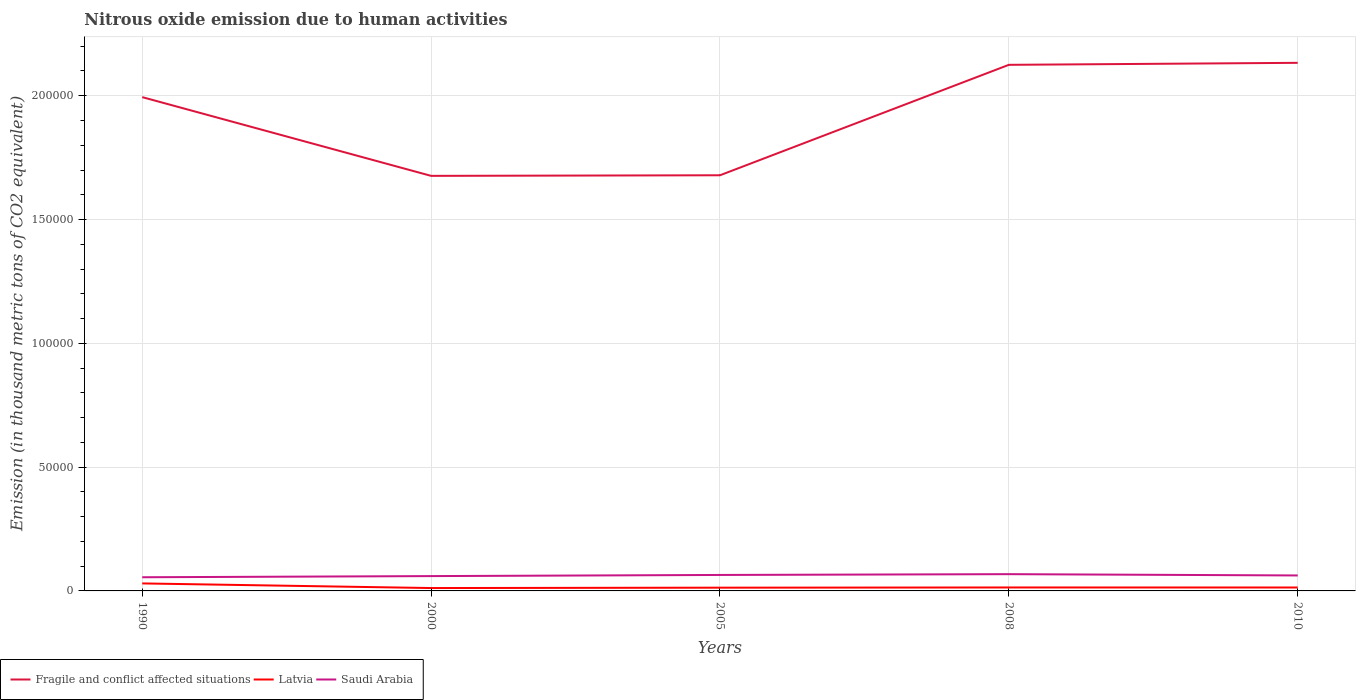Across all years, what is the maximum amount of nitrous oxide emitted in Saudi Arabia?
Your response must be concise. 5523.5. In which year was the amount of nitrous oxide emitted in Latvia maximum?
Give a very brief answer. 2000. What is the total amount of nitrous oxide emitted in Latvia in the graph?
Provide a succinct answer. 1872.4. What is the difference between the highest and the second highest amount of nitrous oxide emitted in Saudi Arabia?
Your answer should be very brief. 1249.7. How many lines are there?
Offer a very short reply. 3. Are the values on the major ticks of Y-axis written in scientific E-notation?
Make the answer very short. No. How many legend labels are there?
Your answer should be very brief. 3. How are the legend labels stacked?
Provide a short and direct response. Horizontal. What is the title of the graph?
Ensure brevity in your answer.  Nitrous oxide emission due to human activities. Does "Netherlands" appear as one of the legend labels in the graph?
Provide a succinct answer. No. What is the label or title of the Y-axis?
Your response must be concise. Emission (in thousand metric tons of CO2 equivalent). What is the Emission (in thousand metric tons of CO2 equivalent) of Fragile and conflict affected situations in 1990?
Your answer should be compact. 1.99e+05. What is the Emission (in thousand metric tons of CO2 equivalent) of Latvia in 1990?
Make the answer very short. 3031.8. What is the Emission (in thousand metric tons of CO2 equivalent) in Saudi Arabia in 1990?
Provide a short and direct response. 5523.5. What is the Emission (in thousand metric tons of CO2 equivalent) in Fragile and conflict affected situations in 2000?
Offer a very short reply. 1.68e+05. What is the Emission (in thousand metric tons of CO2 equivalent) in Latvia in 2000?
Make the answer very short. 1159.4. What is the Emission (in thousand metric tons of CO2 equivalent) of Saudi Arabia in 2000?
Make the answer very short. 5988.8. What is the Emission (in thousand metric tons of CO2 equivalent) in Fragile and conflict affected situations in 2005?
Your response must be concise. 1.68e+05. What is the Emission (in thousand metric tons of CO2 equivalent) in Latvia in 2005?
Make the answer very short. 1311.8. What is the Emission (in thousand metric tons of CO2 equivalent) in Saudi Arabia in 2005?
Give a very brief answer. 6446.5. What is the Emission (in thousand metric tons of CO2 equivalent) of Fragile and conflict affected situations in 2008?
Keep it short and to the point. 2.12e+05. What is the Emission (in thousand metric tons of CO2 equivalent) in Latvia in 2008?
Your answer should be very brief. 1391.9. What is the Emission (in thousand metric tons of CO2 equivalent) in Saudi Arabia in 2008?
Provide a succinct answer. 6773.2. What is the Emission (in thousand metric tons of CO2 equivalent) of Fragile and conflict affected situations in 2010?
Give a very brief answer. 2.13e+05. What is the Emission (in thousand metric tons of CO2 equivalent) in Latvia in 2010?
Give a very brief answer. 1383. What is the Emission (in thousand metric tons of CO2 equivalent) of Saudi Arabia in 2010?
Offer a terse response. 6248.8. Across all years, what is the maximum Emission (in thousand metric tons of CO2 equivalent) in Fragile and conflict affected situations?
Make the answer very short. 2.13e+05. Across all years, what is the maximum Emission (in thousand metric tons of CO2 equivalent) in Latvia?
Your answer should be compact. 3031.8. Across all years, what is the maximum Emission (in thousand metric tons of CO2 equivalent) in Saudi Arabia?
Provide a short and direct response. 6773.2. Across all years, what is the minimum Emission (in thousand metric tons of CO2 equivalent) of Fragile and conflict affected situations?
Keep it short and to the point. 1.68e+05. Across all years, what is the minimum Emission (in thousand metric tons of CO2 equivalent) in Latvia?
Your response must be concise. 1159.4. Across all years, what is the minimum Emission (in thousand metric tons of CO2 equivalent) in Saudi Arabia?
Your answer should be very brief. 5523.5. What is the total Emission (in thousand metric tons of CO2 equivalent) of Fragile and conflict affected situations in the graph?
Provide a succinct answer. 9.61e+05. What is the total Emission (in thousand metric tons of CO2 equivalent) of Latvia in the graph?
Make the answer very short. 8277.9. What is the total Emission (in thousand metric tons of CO2 equivalent) in Saudi Arabia in the graph?
Ensure brevity in your answer.  3.10e+04. What is the difference between the Emission (in thousand metric tons of CO2 equivalent) in Fragile and conflict affected situations in 1990 and that in 2000?
Offer a very short reply. 3.18e+04. What is the difference between the Emission (in thousand metric tons of CO2 equivalent) of Latvia in 1990 and that in 2000?
Make the answer very short. 1872.4. What is the difference between the Emission (in thousand metric tons of CO2 equivalent) in Saudi Arabia in 1990 and that in 2000?
Your answer should be very brief. -465.3. What is the difference between the Emission (in thousand metric tons of CO2 equivalent) in Fragile and conflict affected situations in 1990 and that in 2005?
Your answer should be compact. 3.16e+04. What is the difference between the Emission (in thousand metric tons of CO2 equivalent) in Latvia in 1990 and that in 2005?
Your answer should be very brief. 1720. What is the difference between the Emission (in thousand metric tons of CO2 equivalent) of Saudi Arabia in 1990 and that in 2005?
Keep it short and to the point. -923. What is the difference between the Emission (in thousand metric tons of CO2 equivalent) in Fragile and conflict affected situations in 1990 and that in 2008?
Offer a very short reply. -1.30e+04. What is the difference between the Emission (in thousand metric tons of CO2 equivalent) of Latvia in 1990 and that in 2008?
Your response must be concise. 1639.9. What is the difference between the Emission (in thousand metric tons of CO2 equivalent) of Saudi Arabia in 1990 and that in 2008?
Keep it short and to the point. -1249.7. What is the difference between the Emission (in thousand metric tons of CO2 equivalent) in Fragile and conflict affected situations in 1990 and that in 2010?
Offer a terse response. -1.38e+04. What is the difference between the Emission (in thousand metric tons of CO2 equivalent) in Latvia in 1990 and that in 2010?
Your answer should be very brief. 1648.8. What is the difference between the Emission (in thousand metric tons of CO2 equivalent) in Saudi Arabia in 1990 and that in 2010?
Offer a terse response. -725.3. What is the difference between the Emission (in thousand metric tons of CO2 equivalent) in Fragile and conflict affected situations in 2000 and that in 2005?
Your answer should be very brief. -238.1. What is the difference between the Emission (in thousand metric tons of CO2 equivalent) in Latvia in 2000 and that in 2005?
Ensure brevity in your answer.  -152.4. What is the difference between the Emission (in thousand metric tons of CO2 equivalent) in Saudi Arabia in 2000 and that in 2005?
Offer a very short reply. -457.7. What is the difference between the Emission (in thousand metric tons of CO2 equivalent) of Fragile and conflict affected situations in 2000 and that in 2008?
Your answer should be very brief. -4.48e+04. What is the difference between the Emission (in thousand metric tons of CO2 equivalent) of Latvia in 2000 and that in 2008?
Offer a very short reply. -232.5. What is the difference between the Emission (in thousand metric tons of CO2 equivalent) in Saudi Arabia in 2000 and that in 2008?
Keep it short and to the point. -784.4. What is the difference between the Emission (in thousand metric tons of CO2 equivalent) in Fragile and conflict affected situations in 2000 and that in 2010?
Your answer should be compact. -4.57e+04. What is the difference between the Emission (in thousand metric tons of CO2 equivalent) of Latvia in 2000 and that in 2010?
Keep it short and to the point. -223.6. What is the difference between the Emission (in thousand metric tons of CO2 equivalent) of Saudi Arabia in 2000 and that in 2010?
Offer a very short reply. -260. What is the difference between the Emission (in thousand metric tons of CO2 equivalent) of Fragile and conflict affected situations in 2005 and that in 2008?
Ensure brevity in your answer.  -4.46e+04. What is the difference between the Emission (in thousand metric tons of CO2 equivalent) in Latvia in 2005 and that in 2008?
Provide a short and direct response. -80.1. What is the difference between the Emission (in thousand metric tons of CO2 equivalent) of Saudi Arabia in 2005 and that in 2008?
Ensure brevity in your answer.  -326.7. What is the difference between the Emission (in thousand metric tons of CO2 equivalent) of Fragile and conflict affected situations in 2005 and that in 2010?
Your answer should be compact. -4.54e+04. What is the difference between the Emission (in thousand metric tons of CO2 equivalent) of Latvia in 2005 and that in 2010?
Your answer should be very brief. -71.2. What is the difference between the Emission (in thousand metric tons of CO2 equivalent) of Saudi Arabia in 2005 and that in 2010?
Your response must be concise. 197.7. What is the difference between the Emission (in thousand metric tons of CO2 equivalent) in Fragile and conflict affected situations in 2008 and that in 2010?
Offer a terse response. -807. What is the difference between the Emission (in thousand metric tons of CO2 equivalent) of Saudi Arabia in 2008 and that in 2010?
Offer a terse response. 524.4. What is the difference between the Emission (in thousand metric tons of CO2 equivalent) of Fragile and conflict affected situations in 1990 and the Emission (in thousand metric tons of CO2 equivalent) of Latvia in 2000?
Your answer should be very brief. 1.98e+05. What is the difference between the Emission (in thousand metric tons of CO2 equivalent) in Fragile and conflict affected situations in 1990 and the Emission (in thousand metric tons of CO2 equivalent) in Saudi Arabia in 2000?
Provide a short and direct response. 1.93e+05. What is the difference between the Emission (in thousand metric tons of CO2 equivalent) in Latvia in 1990 and the Emission (in thousand metric tons of CO2 equivalent) in Saudi Arabia in 2000?
Your response must be concise. -2957. What is the difference between the Emission (in thousand metric tons of CO2 equivalent) in Fragile and conflict affected situations in 1990 and the Emission (in thousand metric tons of CO2 equivalent) in Latvia in 2005?
Provide a short and direct response. 1.98e+05. What is the difference between the Emission (in thousand metric tons of CO2 equivalent) in Fragile and conflict affected situations in 1990 and the Emission (in thousand metric tons of CO2 equivalent) in Saudi Arabia in 2005?
Offer a very short reply. 1.93e+05. What is the difference between the Emission (in thousand metric tons of CO2 equivalent) of Latvia in 1990 and the Emission (in thousand metric tons of CO2 equivalent) of Saudi Arabia in 2005?
Keep it short and to the point. -3414.7. What is the difference between the Emission (in thousand metric tons of CO2 equivalent) of Fragile and conflict affected situations in 1990 and the Emission (in thousand metric tons of CO2 equivalent) of Latvia in 2008?
Your answer should be very brief. 1.98e+05. What is the difference between the Emission (in thousand metric tons of CO2 equivalent) of Fragile and conflict affected situations in 1990 and the Emission (in thousand metric tons of CO2 equivalent) of Saudi Arabia in 2008?
Make the answer very short. 1.93e+05. What is the difference between the Emission (in thousand metric tons of CO2 equivalent) of Latvia in 1990 and the Emission (in thousand metric tons of CO2 equivalent) of Saudi Arabia in 2008?
Your answer should be very brief. -3741.4. What is the difference between the Emission (in thousand metric tons of CO2 equivalent) of Fragile and conflict affected situations in 1990 and the Emission (in thousand metric tons of CO2 equivalent) of Latvia in 2010?
Make the answer very short. 1.98e+05. What is the difference between the Emission (in thousand metric tons of CO2 equivalent) in Fragile and conflict affected situations in 1990 and the Emission (in thousand metric tons of CO2 equivalent) in Saudi Arabia in 2010?
Keep it short and to the point. 1.93e+05. What is the difference between the Emission (in thousand metric tons of CO2 equivalent) of Latvia in 1990 and the Emission (in thousand metric tons of CO2 equivalent) of Saudi Arabia in 2010?
Make the answer very short. -3217. What is the difference between the Emission (in thousand metric tons of CO2 equivalent) of Fragile and conflict affected situations in 2000 and the Emission (in thousand metric tons of CO2 equivalent) of Latvia in 2005?
Offer a terse response. 1.66e+05. What is the difference between the Emission (in thousand metric tons of CO2 equivalent) of Fragile and conflict affected situations in 2000 and the Emission (in thousand metric tons of CO2 equivalent) of Saudi Arabia in 2005?
Provide a short and direct response. 1.61e+05. What is the difference between the Emission (in thousand metric tons of CO2 equivalent) in Latvia in 2000 and the Emission (in thousand metric tons of CO2 equivalent) in Saudi Arabia in 2005?
Offer a terse response. -5287.1. What is the difference between the Emission (in thousand metric tons of CO2 equivalent) of Fragile and conflict affected situations in 2000 and the Emission (in thousand metric tons of CO2 equivalent) of Latvia in 2008?
Keep it short and to the point. 1.66e+05. What is the difference between the Emission (in thousand metric tons of CO2 equivalent) in Fragile and conflict affected situations in 2000 and the Emission (in thousand metric tons of CO2 equivalent) in Saudi Arabia in 2008?
Keep it short and to the point. 1.61e+05. What is the difference between the Emission (in thousand metric tons of CO2 equivalent) in Latvia in 2000 and the Emission (in thousand metric tons of CO2 equivalent) in Saudi Arabia in 2008?
Offer a terse response. -5613.8. What is the difference between the Emission (in thousand metric tons of CO2 equivalent) in Fragile and conflict affected situations in 2000 and the Emission (in thousand metric tons of CO2 equivalent) in Latvia in 2010?
Make the answer very short. 1.66e+05. What is the difference between the Emission (in thousand metric tons of CO2 equivalent) in Fragile and conflict affected situations in 2000 and the Emission (in thousand metric tons of CO2 equivalent) in Saudi Arabia in 2010?
Ensure brevity in your answer.  1.61e+05. What is the difference between the Emission (in thousand metric tons of CO2 equivalent) of Latvia in 2000 and the Emission (in thousand metric tons of CO2 equivalent) of Saudi Arabia in 2010?
Your answer should be very brief. -5089.4. What is the difference between the Emission (in thousand metric tons of CO2 equivalent) in Fragile and conflict affected situations in 2005 and the Emission (in thousand metric tons of CO2 equivalent) in Latvia in 2008?
Your response must be concise. 1.66e+05. What is the difference between the Emission (in thousand metric tons of CO2 equivalent) in Fragile and conflict affected situations in 2005 and the Emission (in thousand metric tons of CO2 equivalent) in Saudi Arabia in 2008?
Ensure brevity in your answer.  1.61e+05. What is the difference between the Emission (in thousand metric tons of CO2 equivalent) of Latvia in 2005 and the Emission (in thousand metric tons of CO2 equivalent) of Saudi Arabia in 2008?
Offer a terse response. -5461.4. What is the difference between the Emission (in thousand metric tons of CO2 equivalent) of Fragile and conflict affected situations in 2005 and the Emission (in thousand metric tons of CO2 equivalent) of Latvia in 2010?
Provide a succinct answer. 1.66e+05. What is the difference between the Emission (in thousand metric tons of CO2 equivalent) in Fragile and conflict affected situations in 2005 and the Emission (in thousand metric tons of CO2 equivalent) in Saudi Arabia in 2010?
Keep it short and to the point. 1.62e+05. What is the difference between the Emission (in thousand metric tons of CO2 equivalent) in Latvia in 2005 and the Emission (in thousand metric tons of CO2 equivalent) in Saudi Arabia in 2010?
Ensure brevity in your answer.  -4937. What is the difference between the Emission (in thousand metric tons of CO2 equivalent) of Fragile and conflict affected situations in 2008 and the Emission (in thousand metric tons of CO2 equivalent) of Latvia in 2010?
Give a very brief answer. 2.11e+05. What is the difference between the Emission (in thousand metric tons of CO2 equivalent) of Fragile and conflict affected situations in 2008 and the Emission (in thousand metric tons of CO2 equivalent) of Saudi Arabia in 2010?
Offer a terse response. 2.06e+05. What is the difference between the Emission (in thousand metric tons of CO2 equivalent) of Latvia in 2008 and the Emission (in thousand metric tons of CO2 equivalent) of Saudi Arabia in 2010?
Make the answer very short. -4856.9. What is the average Emission (in thousand metric tons of CO2 equivalent) of Fragile and conflict affected situations per year?
Make the answer very short. 1.92e+05. What is the average Emission (in thousand metric tons of CO2 equivalent) of Latvia per year?
Provide a succinct answer. 1655.58. What is the average Emission (in thousand metric tons of CO2 equivalent) of Saudi Arabia per year?
Give a very brief answer. 6196.16. In the year 1990, what is the difference between the Emission (in thousand metric tons of CO2 equivalent) in Fragile and conflict affected situations and Emission (in thousand metric tons of CO2 equivalent) in Latvia?
Offer a terse response. 1.96e+05. In the year 1990, what is the difference between the Emission (in thousand metric tons of CO2 equivalent) of Fragile and conflict affected situations and Emission (in thousand metric tons of CO2 equivalent) of Saudi Arabia?
Your answer should be very brief. 1.94e+05. In the year 1990, what is the difference between the Emission (in thousand metric tons of CO2 equivalent) of Latvia and Emission (in thousand metric tons of CO2 equivalent) of Saudi Arabia?
Ensure brevity in your answer.  -2491.7. In the year 2000, what is the difference between the Emission (in thousand metric tons of CO2 equivalent) of Fragile and conflict affected situations and Emission (in thousand metric tons of CO2 equivalent) of Latvia?
Provide a short and direct response. 1.66e+05. In the year 2000, what is the difference between the Emission (in thousand metric tons of CO2 equivalent) in Fragile and conflict affected situations and Emission (in thousand metric tons of CO2 equivalent) in Saudi Arabia?
Your response must be concise. 1.62e+05. In the year 2000, what is the difference between the Emission (in thousand metric tons of CO2 equivalent) of Latvia and Emission (in thousand metric tons of CO2 equivalent) of Saudi Arabia?
Ensure brevity in your answer.  -4829.4. In the year 2005, what is the difference between the Emission (in thousand metric tons of CO2 equivalent) of Fragile and conflict affected situations and Emission (in thousand metric tons of CO2 equivalent) of Latvia?
Give a very brief answer. 1.67e+05. In the year 2005, what is the difference between the Emission (in thousand metric tons of CO2 equivalent) of Fragile and conflict affected situations and Emission (in thousand metric tons of CO2 equivalent) of Saudi Arabia?
Offer a terse response. 1.61e+05. In the year 2005, what is the difference between the Emission (in thousand metric tons of CO2 equivalent) in Latvia and Emission (in thousand metric tons of CO2 equivalent) in Saudi Arabia?
Give a very brief answer. -5134.7. In the year 2008, what is the difference between the Emission (in thousand metric tons of CO2 equivalent) of Fragile and conflict affected situations and Emission (in thousand metric tons of CO2 equivalent) of Latvia?
Provide a succinct answer. 2.11e+05. In the year 2008, what is the difference between the Emission (in thousand metric tons of CO2 equivalent) in Fragile and conflict affected situations and Emission (in thousand metric tons of CO2 equivalent) in Saudi Arabia?
Provide a succinct answer. 2.06e+05. In the year 2008, what is the difference between the Emission (in thousand metric tons of CO2 equivalent) of Latvia and Emission (in thousand metric tons of CO2 equivalent) of Saudi Arabia?
Your response must be concise. -5381.3. In the year 2010, what is the difference between the Emission (in thousand metric tons of CO2 equivalent) of Fragile and conflict affected situations and Emission (in thousand metric tons of CO2 equivalent) of Latvia?
Make the answer very short. 2.12e+05. In the year 2010, what is the difference between the Emission (in thousand metric tons of CO2 equivalent) in Fragile and conflict affected situations and Emission (in thousand metric tons of CO2 equivalent) in Saudi Arabia?
Make the answer very short. 2.07e+05. In the year 2010, what is the difference between the Emission (in thousand metric tons of CO2 equivalent) in Latvia and Emission (in thousand metric tons of CO2 equivalent) in Saudi Arabia?
Your answer should be compact. -4865.8. What is the ratio of the Emission (in thousand metric tons of CO2 equivalent) in Fragile and conflict affected situations in 1990 to that in 2000?
Your answer should be very brief. 1.19. What is the ratio of the Emission (in thousand metric tons of CO2 equivalent) of Latvia in 1990 to that in 2000?
Make the answer very short. 2.62. What is the ratio of the Emission (in thousand metric tons of CO2 equivalent) of Saudi Arabia in 1990 to that in 2000?
Make the answer very short. 0.92. What is the ratio of the Emission (in thousand metric tons of CO2 equivalent) in Fragile and conflict affected situations in 1990 to that in 2005?
Offer a terse response. 1.19. What is the ratio of the Emission (in thousand metric tons of CO2 equivalent) of Latvia in 1990 to that in 2005?
Provide a short and direct response. 2.31. What is the ratio of the Emission (in thousand metric tons of CO2 equivalent) in Saudi Arabia in 1990 to that in 2005?
Your answer should be very brief. 0.86. What is the ratio of the Emission (in thousand metric tons of CO2 equivalent) of Fragile and conflict affected situations in 1990 to that in 2008?
Make the answer very short. 0.94. What is the ratio of the Emission (in thousand metric tons of CO2 equivalent) in Latvia in 1990 to that in 2008?
Offer a terse response. 2.18. What is the ratio of the Emission (in thousand metric tons of CO2 equivalent) in Saudi Arabia in 1990 to that in 2008?
Your answer should be very brief. 0.82. What is the ratio of the Emission (in thousand metric tons of CO2 equivalent) in Fragile and conflict affected situations in 1990 to that in 2010?
Provide a succinct answer. 0.94. What is the ratio of the Emission (in thousand metric tons of CO2 equivalent) in Latvia in 1990 to that in 2010?
Your answer should be compact. 2.19. What is the ratio of the Emission (in thousand metric tons of CO2 equivalent) of Saudi Arabia in 1990 to that in 2010?
Ensure brevity in your answer.  0.88. What is the ratio of the Emission (in thousand metric tons of CO2 equivalent) in Fragile and conflict affected situations in 2000 to that in 2005?
Ensure brevity in your answer.  1. What is the ratio of the Emission (in thousand metric tons of CO2 equivalent) in Latvia in 2000 to that in 2005?
Ensure brevity in your answer.  0.88. What is the ratio of the Emission (in thousand metric tons of CO2 equivalent) of Saudi Arabia in 2000 to that in 2005?
Offer a terse response. 0.93. What is the ratio of the Emission (in thousand metric tons of CO2 equivalent) in Fragile and conflict affected situations in 2000 to that in 2008?
Provide a succinct answer. 0.79. What is the ratio of the Emission (in thousand metric tons of CO2 equivalent) of Latvia in 2000 to that in 2008?
Your answer should be compact. 0.83. What is the ratio of the Emission (in thousand metric tons of CO2 equivalent) of Saudi Arabia in 2000 to that in 2008?
Your response must be concise. 0.88. What is the ratio of the Emission (in thousand metric tons of CO2 equivalent) of Fragile and conflict affected situations in 2000 to that in 2010?
Ensure brevity in your answer.  0.79. What is the ratio of the Emission (in thousand metric tons of CO2 equivalent) of Latvia in 2000 to that in 2010?
Your answer should be compact. 0.84. What is the ratio of the Emission (in thousand metric tons of CO2 equivalent) of Saudi Arabia in 2000 to that in 2010?
Your answer should be very brief. 0.96. What is the ratio of the Emission (in thousand metric tons of CO2 equivalent) of Fragile and conflict affected situations in 2005 to that in 2008?
Your response must be concise. 0.79. What is the ratio of the Emission (in thousand metric tons of CO2 equivalent) of Latvia in 2005 to that in 2008?
Keep it short and to the point. 0.94. What is the ratio of the Emission (in thousand metric tons of CO2 equivalent) of Saudi Arabia in 2005 to that in 2008?
Your answer should be compact. 0.95. What is the ratio of the Emission (in thousand metric tons of CO2 equivalent) in Fragile and conflict affected situations in 2005 to that in 2010?
Your response must be concise. 0.79. What is the ratio of the Emission (in thousand metric tons of CO2 equivalent) of Latvia in 2005 to that in 2010?
Make the answer very short. 0.95. What is the ratio of the Emission (in thousand metric tons of CO2 equivalent) in Saudi Arabia in 2005 to that in 2010?
Provide a succinct answer. 1.03. What is the ratio of the Emission (in thousand metric tons of CO2 equivalent) in Fragile and conflict affected situations in 2008 to that in 2010?
Keep it short and to the point. 1. What is the ratio of the Emission (in thousand metric tons of CO2 equivalent) of Latvia in 2008 to that in 2010?
Provide a short and direct response. 1.01. What is the ratio of the Emission (in thousand metric tons of CO2 equivalent) of Saudi Arabia in 2008 to that in 2010?
Offer a terse response. 1.08. What is the difference between the highest and the second highest Emission (in thousand metric tons of CO2 equivalent) of Fragile and conflict affected situations?
Give a very brief answer. 807. What is the difference between the highest and the second highest Emission (in thousand metric tons of CO2 equivalent) of Latvia?
Provide a short and direct response. 1639.9. What is the difference between the highest and the second highest Emission (in thousand metric tons of CO2 equivalent) of Saudi Arabia?
Offer a terse response. 326.7. What is the difference between the highest and the lowest Emission (in thousand metric tons of CO2 equivalent) in Fragile and conflict affected situations?
Make the answer very short. 4.57e+04. What is the difference between the highest and the lowest Emission (in thousand metric tons of CO2 equivalent) in Latvia?
Provide a short and direct response. 1872.4. What is the difference between the highest and the lowest Emission (in thousand metric tons of CO2 equivalent) of Saudi Arabia?
Your answer should be compact. 1249.7. 